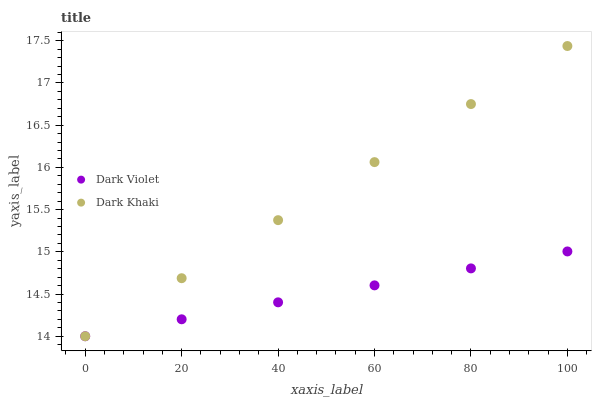Does Dark Violet have the minimum area under the curve?
Answer yes or no. Yes. Does Dark Khaki have the maximum area under the curve?
Answer yes or no. Yes. Does Dark Violet have the maximum area under the curve?
Answer yes or no. No. Is Dark Khaki the smoothest?
Answer yes or no. Yes. Is Dark Violet the roughest?
Answer yes or no. Yes. Is Dark Violet the smoothest?
Answer yes or no. No. Does Dark Khaki have the lowest value?
Answer yes or no. Yes. Does Dark Khaki have the highest value?
Answer yes or no. Yes. Does Dark Violet have the highest value?
Answer yes or no. No. Does Dark Violet intersect Dark Khaki?
Answer yes or no. Yes. Is Dark Violet less than Dark Khaki?
Answer yes or no. No. Is Dark Violet greater than Dark Khaki?
Answer yes or no. No. 